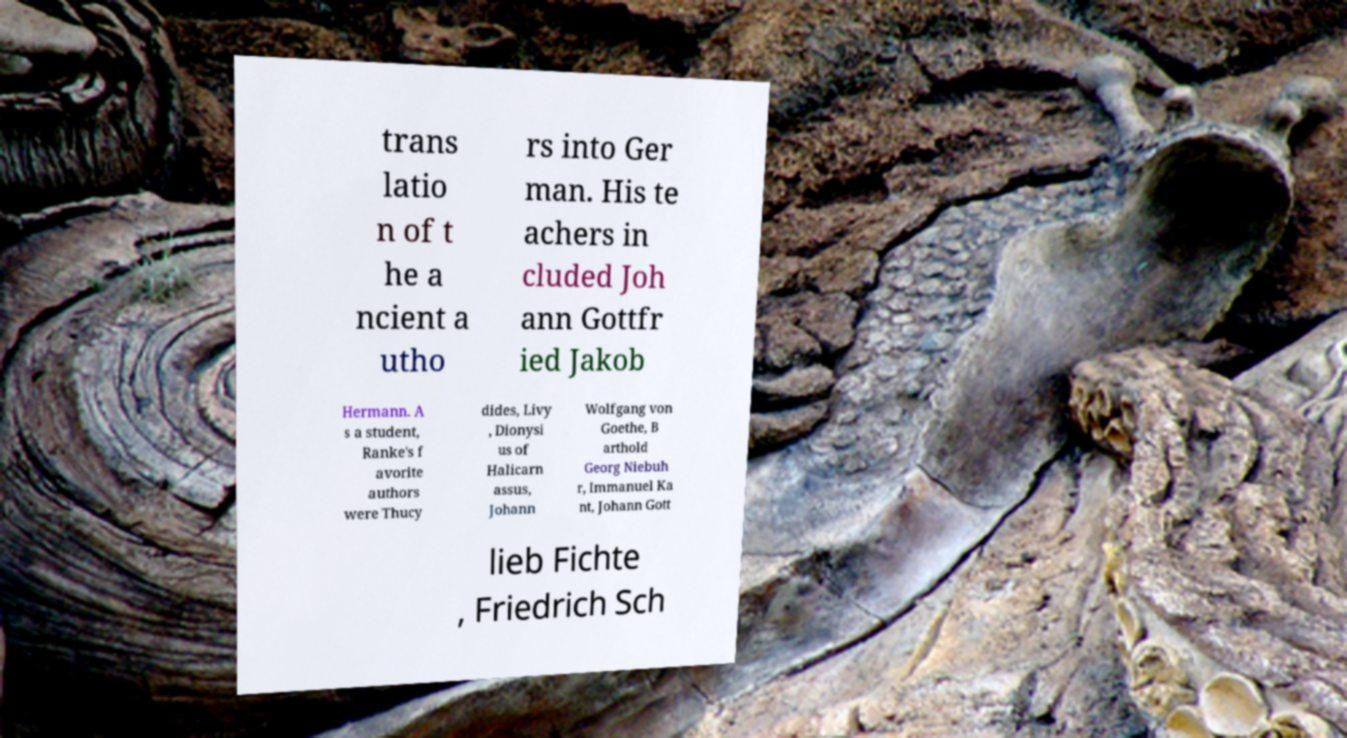Please identify and transcribe the text found in this image. trans latio n of t he a ncient a utho rs into Ger man. His te achers in cluded Joh ann Gottfr ied Jakob Hermann. A s a student, Ranke's f avorite authors were Thucy dides, Livy , Dionysi us of Halicarn assus, Johann Wolfgang von Goethe, B arthold Georg Niebuh r, Immanuel Ka nt, Johann Gott lieb Fichte , Friedrich Sch 